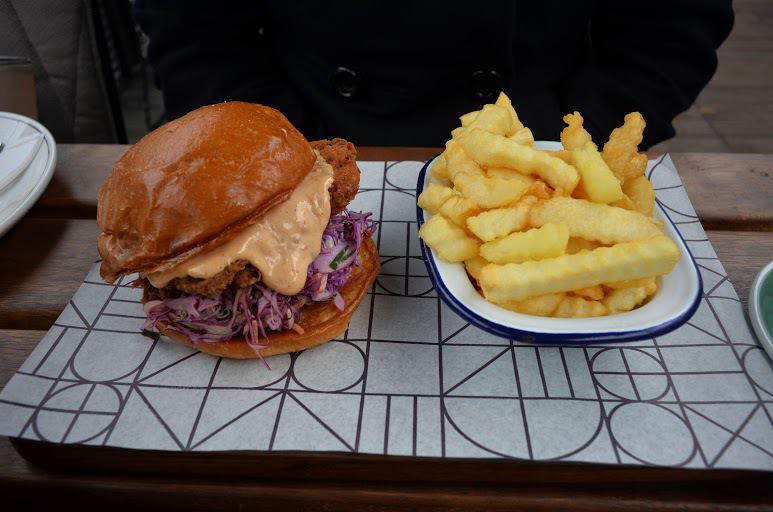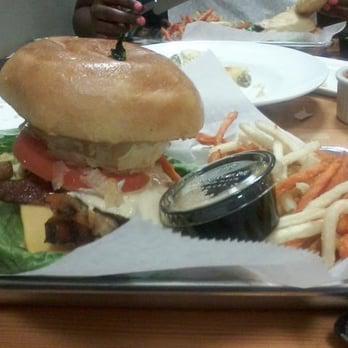The first image is the image on the left, the second image is the image on the right. Given the left and right images, does the statement "There are two burgers sitting on paper." hold true? Answer yes or no. Yes. The first image is the image on the left, the second image is the image on the right. Assess this claim about the two images: "An image shows a burger next to slender french fries on a white paper in a container.". Correct or not? Answer yes or no. Yes. 